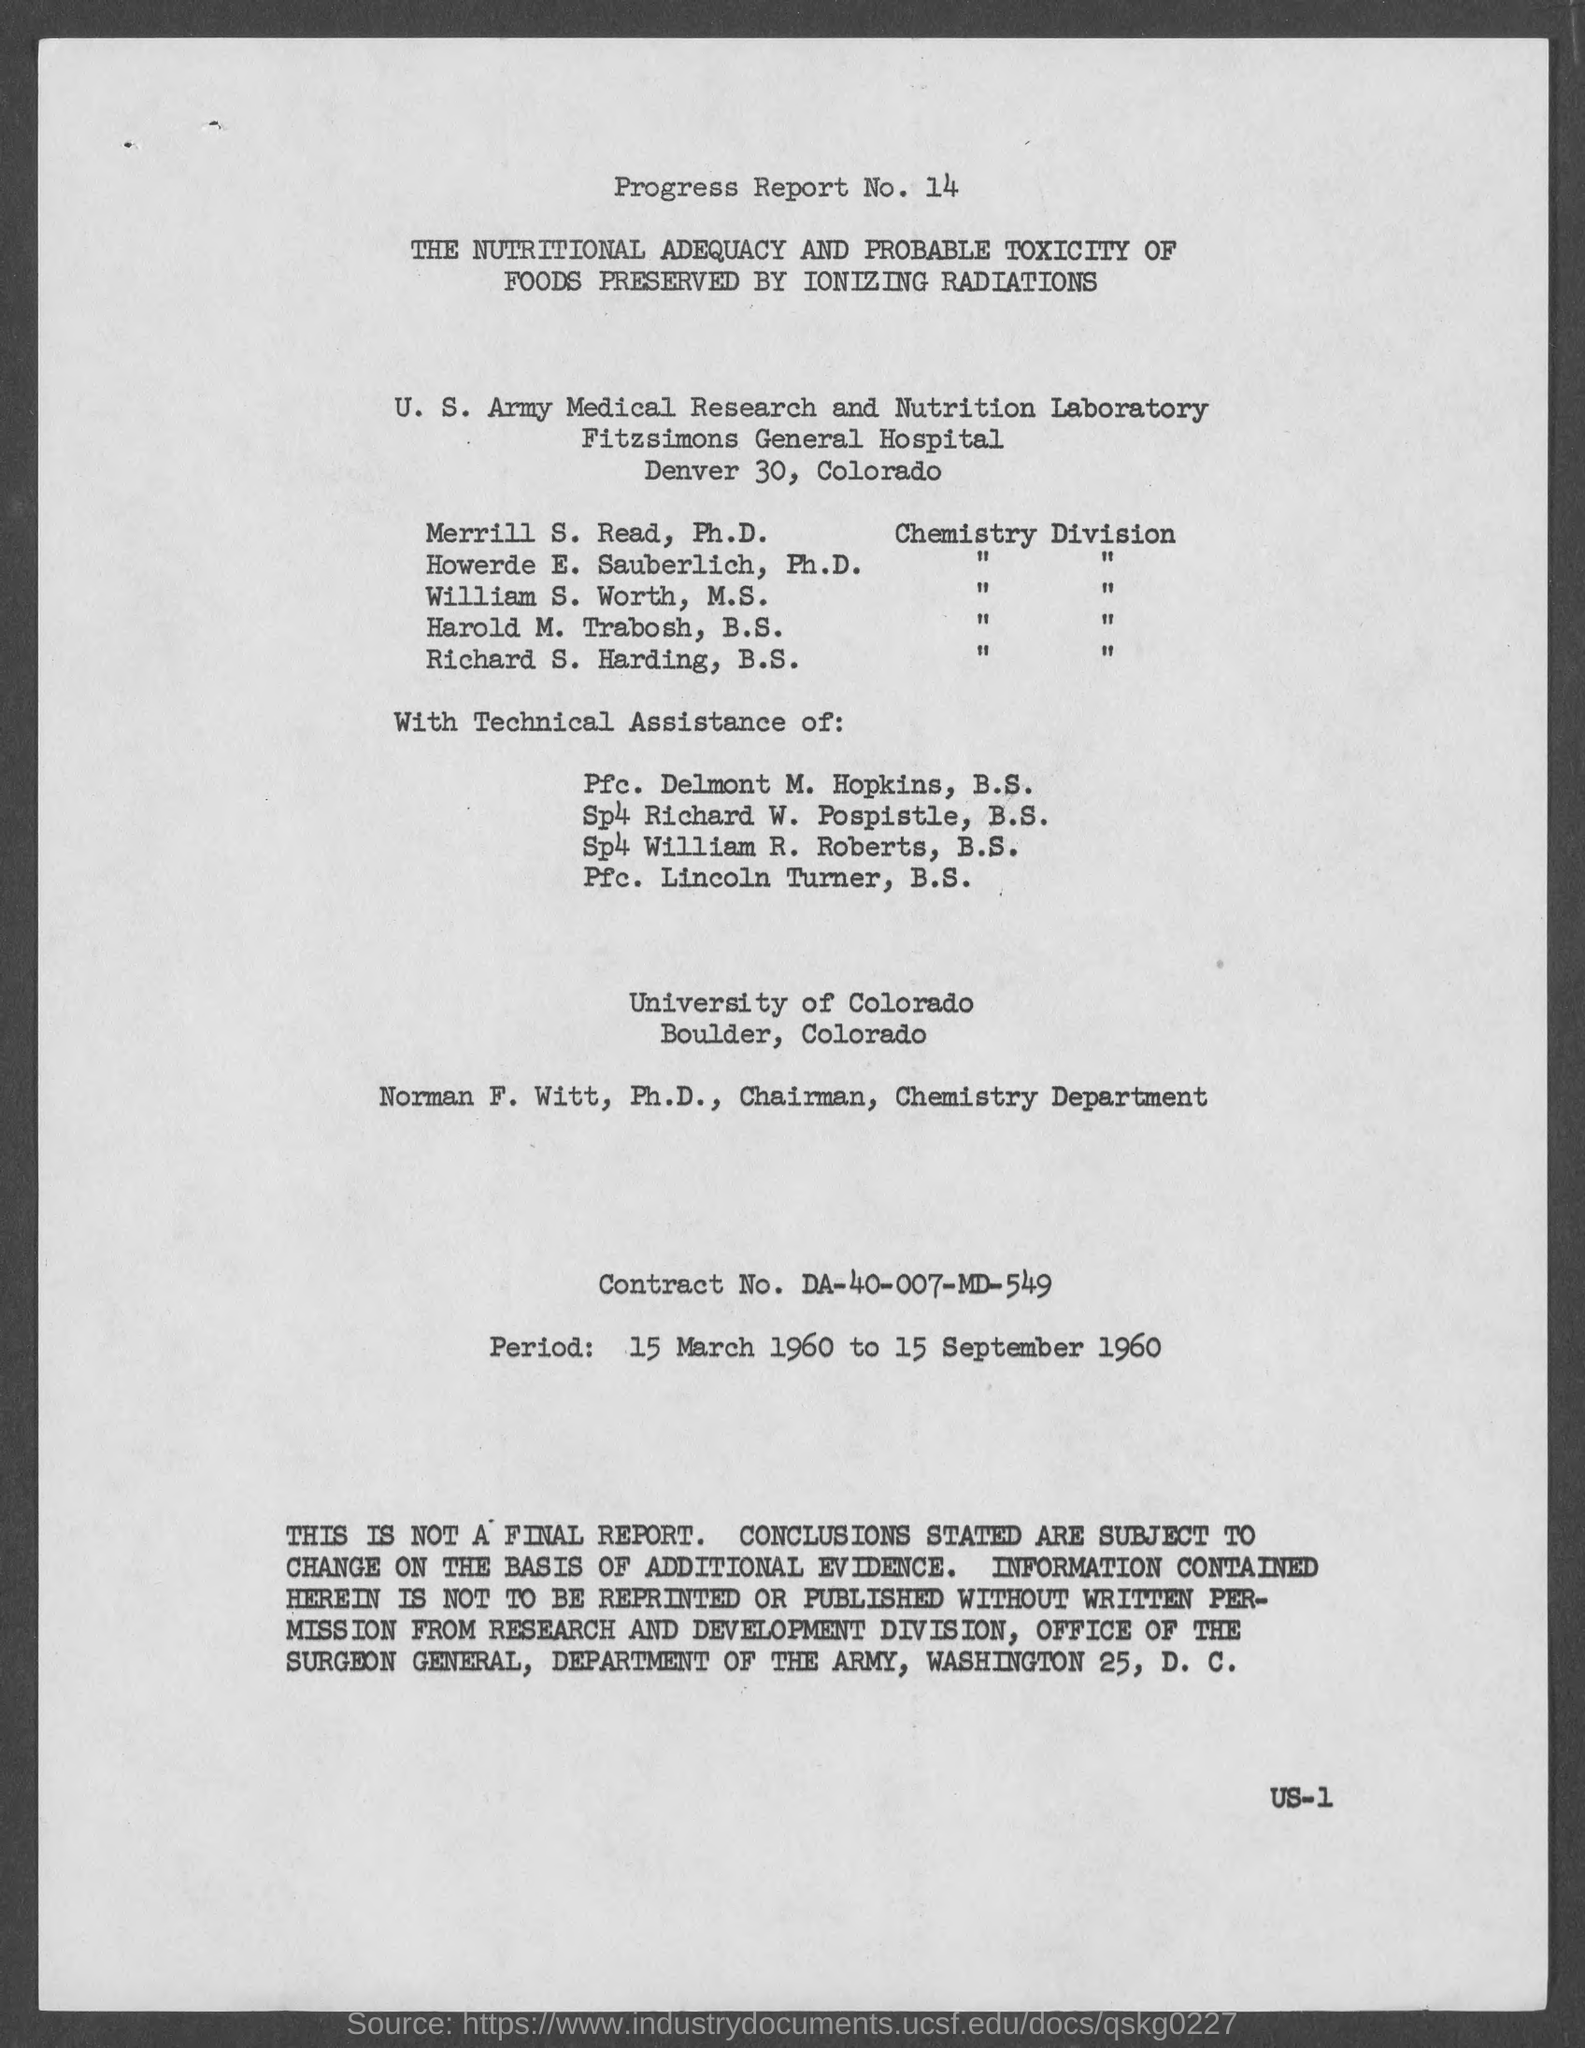Draw attention to some important aspects in this diagram. Fitzsimons General Hospital is located at a street address in Denver, and the specific address is 30... The contract number is DA-40-007-MD-549. The period from March 15, 1960 to September 15, 1960 is? The University of Colorado is located in Boulder County. The progress report number is 14. 